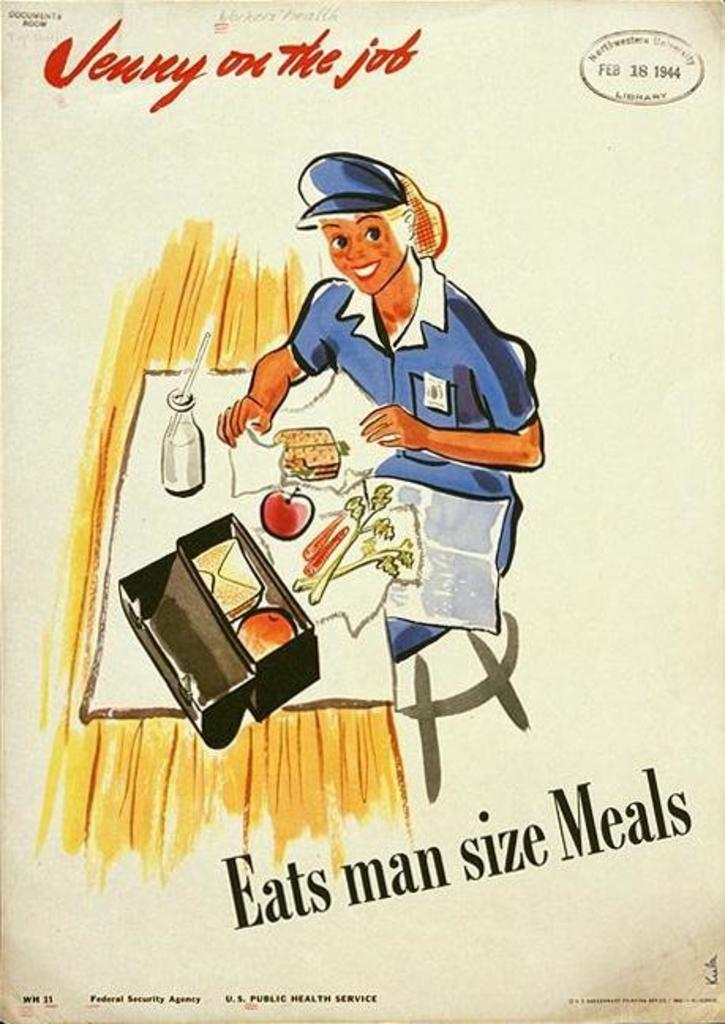<image>
Give a short and clear explanation of the subsequent image. An poster shows a woman eating a man sized meal. 